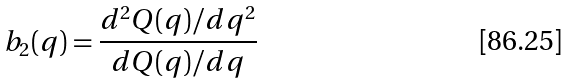<formula> <loc_0><loc_0><loc_500><loc_500>b _ { 2 } ( q ) = \frac { d ^ { 2 } Q ( q ) / d q ^ { 2 } } { d Q ( q ) / d q }</formula> 